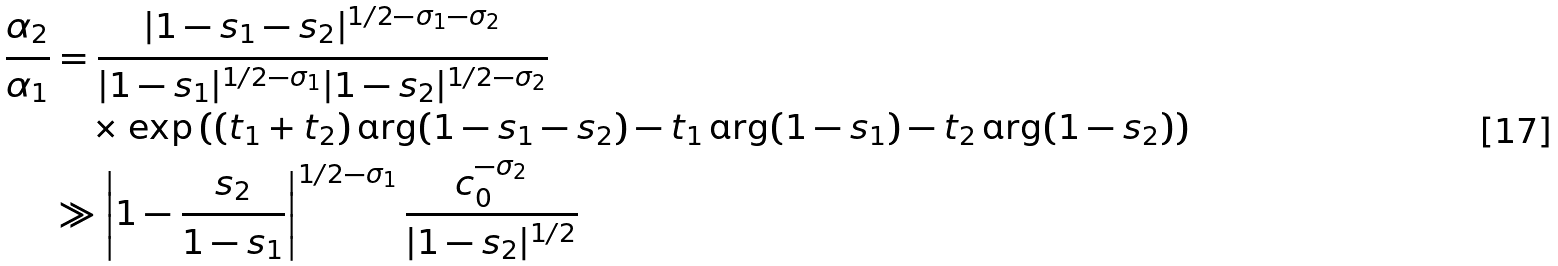<formula> <loc_0><loc_0><loc_500><loc_500>\frac { \alpha _ { 2 } } { \alpha _ { 1 } } & = \frac { | 1 - s _ { 1 } - s _ { 2 } | ^ { 1 / 2 - \sigma _ { 1 } - \sigma _ { 2 } } } { | 1 - s _ { 1 } | ^ { 1 / 2 - \sigma _ { 1 } } | 1 - s _ { 2 } | ^ { 1 / 2 - \sigma _ { 2 } } } \\ & \quad \times \exp \left ( ( t _ { 1 } + t _ { 2 } ) \arg ( 1 - s _ { 1 } - s _ { 2 } ) - t _ { 1 } \arg ( 1 - s _ { 1 } ) - t _ { 2 } \arg ( 1 - s _ { 2 } ) \right ) \\ & \gg \left | 1 - \frac { s _ { 2 } } { 1 - s _ { 1 } } \right | ^ { 1 / 2 - \sigma _ { 1 } } \frac { c _ { 0 } ^ { - \sigma _ { 2 } } } { | 1 - s _ { 2 } | ^ { 1 / 2 } }</formula> 